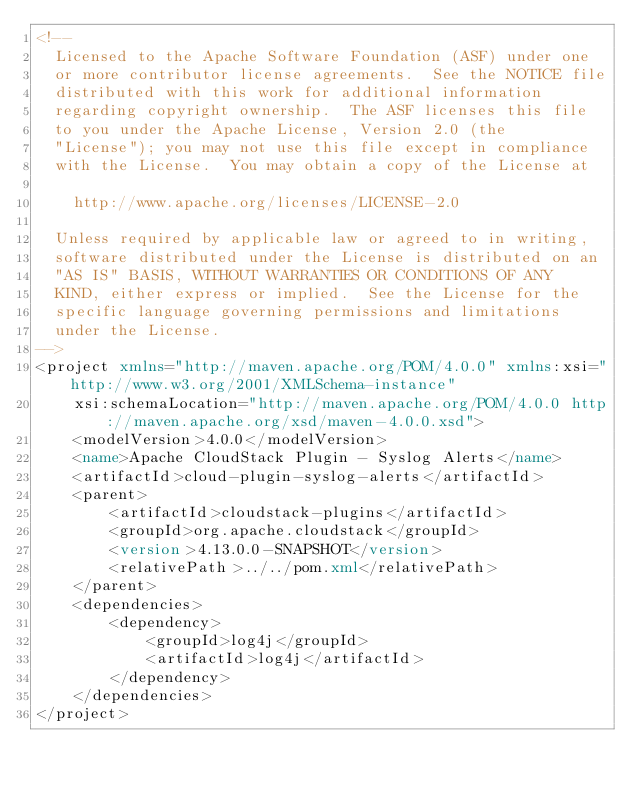Convert code to text. <code><loc_0><loc_0><loc_500><loc_500><_XML_><!--
  Licensed to the Apache Software Foundation (ASF) under one
  or more contributor license agreements.  See the NOTICE file
  distributed with this work for additional information
  regarding copyright ownership.  The ASF licenses this file
  to you under the Apache License, Version 2.0 (the
  "License"); you may not use this file except in compliance
  with the License.  You may obtain a copy of the License at

    http://www.apache.org/licenses/LICENSE-2.0

  Unless required by applicable law or agreed to in writing,
  software distributed under the License is distributed on an
  "AS IS" BASIS, WITHOUT WARRANTIES OR CONDITIONS OF ANY
  KIND, either express or implied.  See the License for the
  specific language governing permissions and limitations
  under the License.
-->
<project xmlns="http://maven.apache.org/POM/4.0.0" xmlns:xsi="http://www.w3.org/2001/XMLSchema-instance"
    xsi:schemaLocation="http://maven.apache.org/POM/4.0.0 http://maven.apache.org/xsd/maven-4.0.0.xsd">
    <modelVersion>4.0.0</modelVersion>
    <name>Apache CloudStack Plugin - Syslog Alerts</name>
    <artifactId>cloud-plugin-syslog-alerts</artifactId>
    <parent>
        <artifactId>cloudstack-plugins</artifactId>
        <groupId>org.apache.cloudstack</groupId>
        <version>4.13.0.0-SNAPSHOT</version>
        <relativePath>../../pom.xml</relativePath>
    </parent>
    <dependencies>
        <dependency>
            <groupId>log4j</groupId>
            <artifactId>log4j</artifactId>
        </dependency>
    </dependencies>
</project>
</code> 